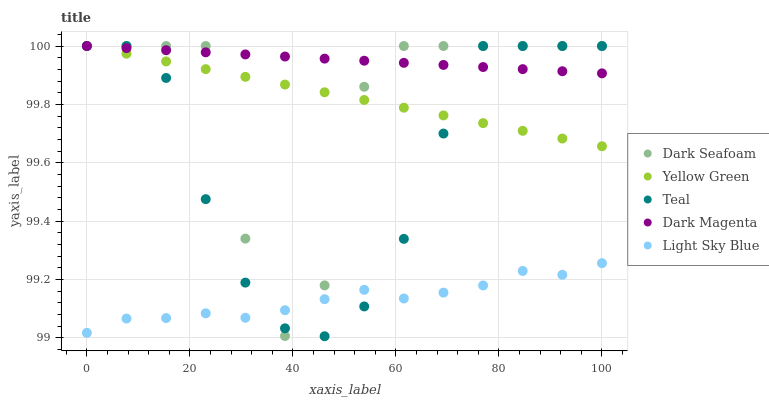Does Light Sky Blue have the minimum area under the curve?
Answer yes or no. Yes. Does Dark Magenta have the maximum area under the curve?
Answer yes or no. Yes. Does Yellow Green have the minimum area under the curve?
Answer yes or no. No. Does Yellow Green have the maximum area under the curve?
Answer yes or no. No. Is Yellow Green the smoothest?
Answer yes or no. Yes. Is Dark Seafoam the roughest?
Answer yes or no. Yes. Is Light Sky Blue the smoothest?
Answer yes or no. No. Is Light Sky Blue the roughest?
Answer yes or no. No. Does Teal have the lowest value?
Answer yes or no. Yes. Does Light Sky Blue have the lowest value?
Answer yes or no. No. Does Dark Magenta have the highest value?
Answer yes or no. Yes. Does Light Sky Blue have the highest value?
Answer yes or no. No. Is Light Sky Blue less than Yellow Green?
Answer yes or no. Yes. Is Yellow Green greater than Light Sky Blue?
Answer yes or no. Yes. Does Light Sky Blue intersect Teal?
Answer yes or no. Yes. Is Light Sky Blue less than Teal?
Answer yes or no. No. Is Light Sky Blue greater than Teal?
Answer yes or no. No. Does Light Sky Blue intersect Yellow Green?
Answer yes or no. No. 